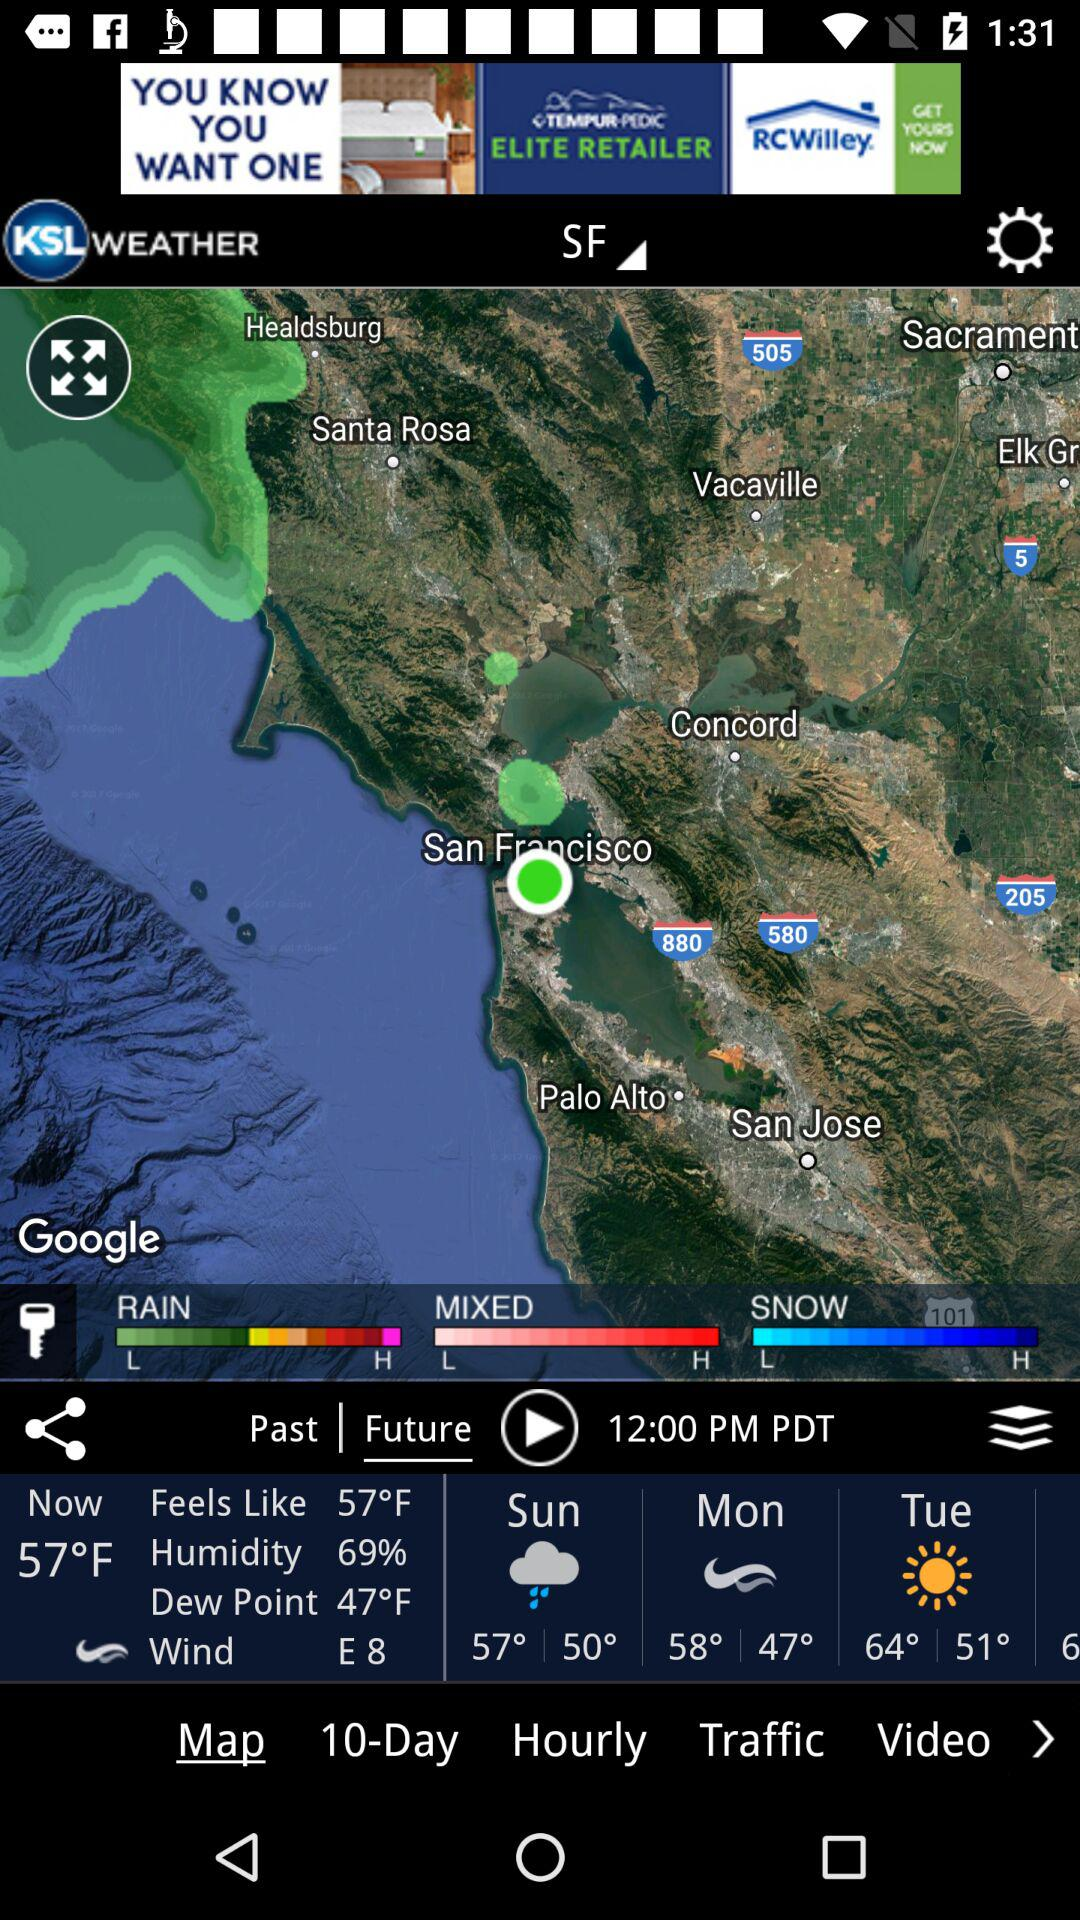How many days are included in the 10-day forecast?
Answer the question using a single word or phrase. 10 